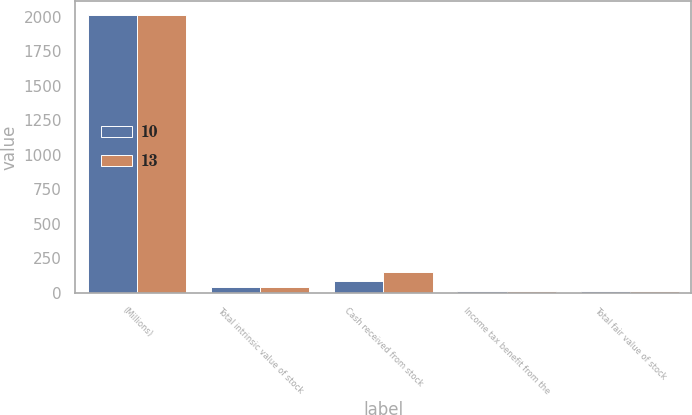<chart> <loc_0><loc_0><loc_500><loc_500><stacked_bar_chart><ecel><fcel>(Millions)<fcel>Total intrinsic value of stock<fcel>Cash received from stock<fcel>Income tax benefit from the<fcel>Total fair value of stock<nl><fcel>10<fcel>2011<fcel>40<fcel>81<fcel>9<fcel>10<nl><fcel>13<fcel>2010<fcel>37<fcel>146<fcel>9<fcel>13<nl></chart> 